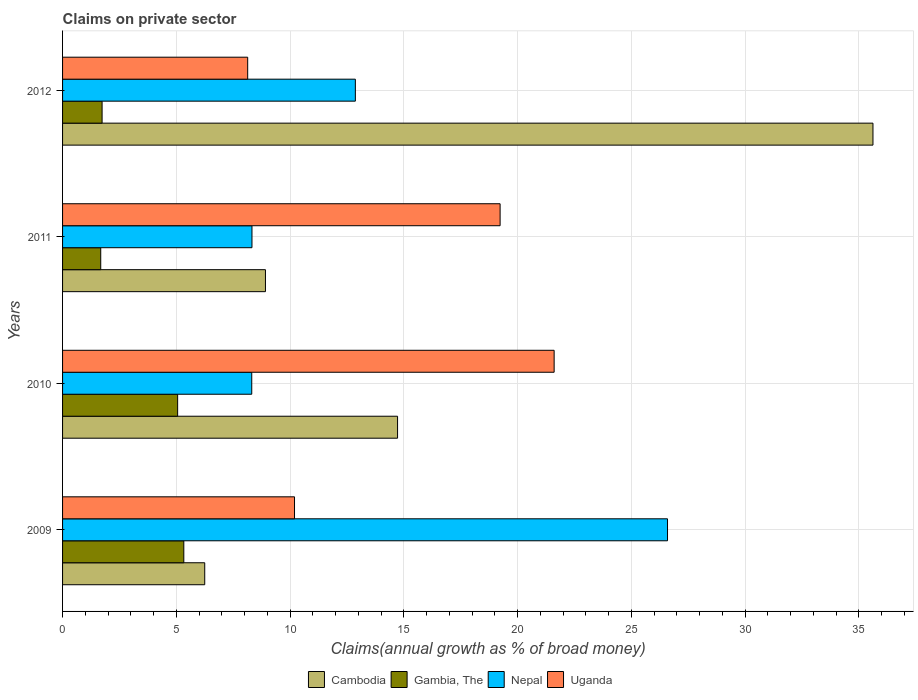How many groups of bars are there?
Your answer should be compact. 4. Are the number of bars on each tick of the Y-axis equal?
Keep it short and to the point. Yes. How many bars are there on the 3rd tick from the top?
Your answer should be compact. 4. How many bars are there on the 4th tick from the bottom?
Offer a terse response. 4. In how many cases, is the number of bars for a given year not equal to the number of legend labels?
Offer a very short reply. 0. What is the percentage of broad money claimed on private sector in Uganda in 2011?
Offer a very short reply. 19.23. Across all years, what is the maximum percentage of broad money claimed on private sector in Nepal?
Make the answer very short. 26.59. Across all years, what is the minimum percentage of broad money claimed on private sector in Uganda?
Your response must be concise. 8.14. In which year was the percentage of broad money claimed on private sector in Uganda maximum?
Your answer should be compact. 2010. What is the total percentage of broad money claimed on private sector in Nepal in the graph?
Your response must be concise. 56.1. What is the difference between the percentage of broad money claimed on private sector in Cambodia in 2009 and that in 2012?
Offer a terse response. -29.37. What is the difference between the percentage of broad money claimed on private sector in Uganda in 2010 and the percentage of broad money claimed on private sector in Nepal in 2009?
Your response must be concise. -4.98. What is the average percentage of broad money claimed on private sector in Nepal per year?
Offer a terse response. 14.03. In the year 2011, what is the difference between the percentage of broad money claimed on private sector in Uganda and percentage of broad money claimed on private sector in Cambodia?
Give a very brief answer. 10.31. What is the ratio of the percentage of broad money claimed on private sector in Gambia, The in 2010 to that in 2012?
Provide a succinct answer. 2.91. Is the difference between the percentage of broad money claimed on private sector in Uganda in 2010 and 2012 greater than the difference between the percentage of broad money claimed on private sector in Cambodia in 2010 and 2012?
Give a very brief answer. Yes. What is the difference between the highest and the second highest percentage of broad money claimed on private sector in Nepal?
Offer a terse response. 13.72. What is the difference between the highest and the lowest percentage of broad money claimed on private sector in Uganda?
Provide a short and direct response. 13.47. In how many years, is the percentage of broad money claimed on private sector in Cambodia greater than the average percentage of broad money claimed on private sector in Cambodia taken over all years?
Give a very brief answer. 1. Is the sum of the percentage of broad money claimed on private sector in Uganda in 2009 and 2011 greater than the maximum percentage of broad money claimed on private sector in Gambia, The across all years?
Offer a terse response. Yes. Is it the case that in every year, the sum of the percentage of broad money claimed on private sector in Nepal and percentage of broad money claimed on private sector in Gambia, The is greater than the sum of percentage of broad money claimed on private sector in Uganda and percentage of broad money claimed on private sector in Cambodia?
Offer a terse response. No. What does the 4th bar from the top in 2012 represents?
Keep it short and to the point. Cambodia. What does the 3rd bar from the bottom in 2010 represents?
Your response must be concise. Nepal. Is it the case that in every year, the sum of the percentage of broad money claimed on private sector in Gambia, The and percentage of broad money claimed on private sector in Nepal is greater than the percentage of broad money claimed on private sector in Uganda?
Give a very brief answer. No. How many bars are there?
Your answer should be very brief. 16. Are all the bars in the graph horizontal?
Your response must be concise. Yes. How many years are there in the graph?
Provide a short and direct response. 4. What is the difference between two consecutive major ticks on the X-axis?
Keep it short and to the point. 5. Are the values on the major ticks of X-axis written in scientific E-notation?
Your answer should be compact. No. Does the graph contain grids?
Offer a terse response. Yes. Where does the legend appear in the graph?
Make the answer very short. Bottom center. How are the legend labels stacked?
Your answer should be compact. Horizontal. What is the title of the graph?
Your response must be concise. Claims on private sector. Does "Togo" appear as one of the legend labels in the graph?
Provide a short and direct response. No. What is the label or title of the X-axis?
Your response must be concise. Claims(annual growth as % of broad money). What is the label or title of the Y-axis?
Offer a terse response. Years. What is the Claims(annual growth as % of broad money) in Cambodia in 2009?
Your answer should be very brief. 6.25. What is the Claims(annual growth as % of broad money) of Gambia, The in 2009?
Provide a short and direct response. 5.33. What is the Claims(annual growth as % of broad money) in Nepal in 2009?
Your answer should be very brief. 26.59. What is the Claims(annual growth as % of broad money) in Uganda in 2009?
Provide a short and direct response. 10.2. What is the Claims(annual growth as % of broad money) in Cambodia in 2010?
Provide a short and direct response. 14.72. What is the Claims(annual growth as % of broad money) of Gambia, The in 2010?
Provide a succinct answer. 5.06. What is the Claims(annual growth as % of broad money) of Nepal in 2010?
Give a very brief answer. 8.32. What is the Claims(annual growth as % of broad money) in Uganda in 2010?
Keep it short and to the point. 21.61. What is the Claims(annual growth as % of broad money) in Cambodia in 2011?
Give a very brief answer. 8.92. What is the Claims(annual growth as % of broad money) of Gambia, The in 2011?
Give a very brief answer. 1.68. What is the Claims(annual growth as % of broad money) in Nepal in 2011?
Ensure brevity in your answer.  8.33. What is the Claims(annual growth as % of broad money) in Uganda in 2011?
Offer a very short reply. 19.23. What is the Claims(annual growth as % of broad money) of Cambodia in 2012?
Your answer should be very brief. 35.62. What is the Claims(annual growth as % of broad money) in Gambia, The in 2012?
Your response must be concise. 1.74. What is the Claims(annual growth as % of broad money) of Nepal in 2012?
Provide a succinct answer. 12.87. What is the Claims(annual growth as % of broad money) in Uganda in 2012?
Keep it short and to the point. 8.14. Across all years, what is the maximum Claims(annual growth as % of broad money) of Cambodia?
Provide a short and direct response. 35.62. Across all years, what is the maximum Claims(annual growth as % of broad money) of Gambia, The?
Provide a short and direct response. 5.33. Across all years, what is the maximum Claims(annual growth as % of broad money) of Nepal?
Provide a succinct answer. 26.59. Across all years, what is the maximum Claims(annual growth as % of broad money) of Uganda?
Your answer should be compact. 21.61. Across all years, what is the minimum Claims(annual growth as % of broad money) of Cambodia?
Offer a very short reply. 6.25. Across all years, what is the minimum Claims(annual growth as % of broad money) in Gambia, The?
Ensure brevity in your answer.  1.68. Across all years, what is the minimum Claims(annual growth as % of broad money) of Nepal?
Your answer should be very brief. 8.32. Across all years, what is the minimum Claims(annual growth as % of broad money) of Uganda?
Your response must be concise. 8.14. What is the total Claims(annual growth as % of broad money) of Cambodia in the graph?
Provide a succinct answer. 65.51. What is the total Claims(annual growth as % of broad money) in Gambia, The in the graph?
Provide a short and direct response. 13.8. What is the total Claims(annual growth as % of broad money) of Nepal in the graph?
Offer a very short reply. 56.1. What is the total Claims(annual growth as % of broad money) of Uganda in the graph?
Provide a succinct answer. 59.17. What is the difference between the Claims(annual growth as % of broad money) in Cambodia in 2009 and that in 2010?
Ensure brevity in your answer.  -8.48. What is the difference between the Claims(annual growth as % of broad money) of Gambia, The in 2009 and that in 2010?
Offer a terse response. 0.27. What is the difference between the Claims(annual growth as % of broad money) of Nepal in 2009 and that in 2010?
Offer a very short reply. 18.27. What is the difference between the Claims(annual growth as % of broad money) in Uganda in 2009 and that in 2010?
Offer a terse response. -11.41. What is the difference between the Claims(annual growth as % of broad money) of Cambodia in 2009 and that in 2011?
Your answer should be compact. -2.67. What is the difference between the Claims(annual growth as % of broad money) of Gambia, The in 2009 and that in 2011?
Keep it short and to the point. 3.65. What is the difference between the Claims(annual growth as % of broad money) in Nepal in 2009 and that in 2011?
Offer a very short reply. 18.27. What is the difference between the Claims(annual growth as % of broad money) of Uganda in 2009 and that in 2011?
Keep it short and to the point. -9.04. What is the difference between the Claims(annual growth as % of broad money) in Cambodia in 2009 and that in 2012?
Keep it short and to the point. -29.37. What is the difference between the Claims(annual growth as % of broad money) of Gambia, The in 2009 and that in 2012?
Your response must be concise. 3.59. What is the difference between the Claims(annual growth as % of broad money) of Nepal in 2009 and that in 2012?
Your answer should be very brief. 13.72. What is the difference between the Claims(annual growth as % of broad money) in Uganda in 2009 and that in 2012?
Offer a very short reply. 2.06. What is the difference between the Claims(annual growth as % of broad money) of Cambodia in 2010 and that in 2011?
Your answer should be very brief. 5.81. What is the difference between the Claims(annual growth as % of broad money) of Gambia, The in 2010 and that in 2011?
Make the answer very short. 3.38. What is the difference between the Claims(annual growth as % of broad money) of Nepal in 2010 and that in 2011?
Your response must be concise. -0.01. What is the difference between the Claims(annual growth as % of broad money) of Uganda in 2010 and that in 2011?
Give a very brief answer. 2.37. What is the difference between the Claims(annual growth as % of broad money) of Cambodia in 2010 and that in 2012?
Your answer should be compact. -20.9. What is the difference between the Claims(annual growth as % of broad money) of Gambia, The in 2010 and that in 2012?
Your response must be concise. 3.32. What is the difference between the Claims(annual growth as % of broad money) in Nepal in 2010 and that in 2012?
Your response must be concise. -4.55. What is the difference between the Claims(annual growth as % of broad money) in Uganda in 2010 and that in 2012?
Your answer should be compact. 13.47. What is the difference between the Claims(annual growth as % of broad money) of Cambodia in 2011 and that in 2012?
Give a very brief answer. -26.7. What is the difference between the Claims(annual growth as % of broad money) of Gambia, The in 2011 and that in 2012?
Make the answer very short. -0.06. What is the difference between the Claims(annual growth as % of broad money) in Nepal in 2011 and that in 2012?
Keep it short and to the point. -4.54. What is the difference between the Claims(annual growth as % of broad money) of Uganda in 2011 and that in 2012?
Ensure brevity in your answer.  11.09. What is the difference between the Claims(annual growth as % of broad money) of Cambodia in 2009 and the Claims(annual growth as % of broad money) of Gambia, The in 2010?
Offer a very short reply. 1.19. What is the difference between the Claims(annual growth as % of broad money) of Cambodia in 2009 and the Claims(annual growth as % of broad money) of Nepal in 2010?
Offer a terse response. -2.07. What is the difference between the Claims(annual growth as % of broad money) in Cambodia in 2009 and the Claims(annual growth as % of broad money) in Uganda in 2010?
Give a very brief answer. -15.36. What is the difference between the Claims(annual growth as % of broad money) in Gambia, The in 2009 and the Claims(annual growth as % of broad money) in Nepal in 2010?
Provide a short and direct response. -2.99. What is the difference between the Claims(annual growth as % of broad money) in Gambia, The in 2009 and the Claims(annual growth as % of broad money) in Uganda in 2010?
Provide a succinct answer. -16.28. What is the difference between the Claims(annual growth as % of broad money) in Nepal in 2009 and the Claims(annual growth as % of broad money) in Uganda in 2010?
Give a very brief answer. 4.98. What is the difference between the Claims(annual growth as % of broad money) of Cambodia in 2009 and the Claims(annual growth as % of broad money) of Gambia, The in 2011?
Provide a succinct answer. 4.57. What is the difference between the Claims(annual growth as % of broad money) in Cambodia in 2009 and the Claims(annual growth as % of broad money) in Nepal in 2011?
Your response must be concise. -2.08. What is the difference between the Claims(annual growth as % of broad money) in Cambodia in 2009 and the Claims(annual growth as % of broad money) in Uganda in 2011?
Provide a short and direct response. -12.98. What is the difference between the Claims(annual growth as % of broad money) in Gambia, The in 2009 and the Claims(annual growth as % of broad money) in Nepal in 2011?
Make the answer very short. -3. What is the difference between the Claims(annual growth as % of broad money) in Gambia, The in 2009 and the Claims(annual growth as % of broad money) in Uganda in 2011?
Offer a very short reply. -13.9. What is the difference between the Claims(annual growth as % of broad money) of Nepal in 2009 and the Claims(annual growth as % of broad money) of Uganda in 2011?
Your response must be concise. 7.36. What is the difference between the Claims(annual growth as % of broad money) of Cambodia in 2009 and the Claims(annual growth as % of broad money) of Gambia, The in 2012?
Offer a very short reply. 4.51. What is the difference between the Claims(annual growth as % of broad money) of Cambodia in 2009 and the Claims(annual growth as % of broad money) of Nepal in 2012?
Your answer should be very brief. -6.62. What is the difference between the Claims(annual growth as % of broad money) of Cambodia in 2009 and the Claims(annual growth as % of broad money) of Uganda in 2012?
Your answer should be compact. -1.89. What is the difference between the Claims(annual growth as % of broad money) in Gambia, The in 2009 and the Claims(annual growth as % of broad money) in Nepal in 2012?
Ensure brevity in your answer.  -7.54. What is the difference between the Claims(annual growth as % of broad money) in Gambia, The in 2009 and the Claims(annual growth as % of broad money) in Uganda in 2012?
Your response must be concise. -2.81. What is the difference between the Claims(annual growth as % of broad money) of Nepal in 2009 and the Claims(annual growth as % of broad money) of Uganda in 2012?
Offer a terse response. 18.45. What is the difference between the Claims(annual growth as % of broad money) in Cambodia in 2010 and the Claims(annual growth as % of broad money) in Gambia, The in 2011?
Offer a very short reply. 13.05. What is the difference between the Claims(annual growth as % of broad money) in Cambodia in 2010 and the Claims(annual growth as % of broad money) in Nepal in 2011?
Your answer should be compact. 6.4. What is the difference between the Claims(annual growth as % of broad money) in Cambodia in 2010 and the Claims(annual growth as % of broad money) in Uganda in 2011?
Your response must be concise. -4.51. What is the difference between the Claims(annual growth as % of broad money) of Gambia, The in 2010 and the Claims(annual growth as % of broad money) of Nepal in 2011?
Provide a short and direct response. -3.27. What is the difference between the Claims(annual growth as % of broad money) in Gambia, The in 2010 and the Claims(annual growth as % of broad money) in Uganda in 2011?
Provide a succinct answer. -14.17. What is the difference between the Claims(annual growth as % of broad money) in Nepal in 2010 and the Claims(annual growth as % of broad money) in Uganda in 2011?
Your response must be concise. -10.92. What is the difference between the Claims(annual growth as % of broad money) in Cambodia in 2010 and the Claims(annual growth as % of broad money) in Gambia, The in 2012?
Keep it short and to the point. 12.99. What is the difference between the Claims(annual growth as % of broad money) in Cambodia in 2010 and the Claims(annual growth as % of broad money) in Nepal in 2012?
Your answer should be compact. 1.85. What is the difference between the Claims(annual growth as % of broad money) in Cambodia in 2010 and the Claims(annual growth as % of broad money) in Uganda in 2012?
Your response must be concise. 6.59. What is the difference between the Claims(annual growth as % of broad money) of Gambia, The in 2010 and the Claims(annual growth as % of broad money) of Nepal in 2012?
Ensure brevity in your answer.  -7.81. What is the difference between the Claims(annual growth as % of broad money) of Gambia, The in 2010 and the Claims(annual growth as % of broad money) of Uganda in 2012?
Your response must be concise. -3.08. What is the difference between the Claims(annual growth as % of broad money) of Nepal in 2010 and the Claims(annual growth as % of broad money) of Uganda in 2012?
Your response must be concise. 0.18. What is the difference between the Claims(annual growth as % of broad money) in Cambodia in 2011 and the Claims(annual growth as % of broad money) in Gambia, The in 2012?
Keep it short and to the point. 7.18. What is the difference between the Claims(annual growth as % of broad money) of Cambodia in 2011 and the Claims(annual growth as % of broad money) of Nepal in 2012?
Your answer should be very brief. -3.95. What is the difference between the Claims(annual growth as % of broad money) in Cambodia in 2011 and the Claims(annual growth as % of broad money) in Uganda in 2012?
Your response must be concise. 0.78. What is the difference between the Claims(annual growth as % of broad money) of Gambia, The in 2011 and the Claims(annual growth as % of broad money) of Nepal in 2012?
Provide a succinct answer. -11.19. What is the difference between the Claims(annual growth as % of broad money) of Gambia, The in 2011 and the Claims(annual growth as % of broad money) of Uganda in 2012?
Make the answer very short. -6.46. What is the difference between the Claims(annual growth as % of broad money) in Nepal in 2011 and the Claims(annual growth as % of broad money) in Uganda in 2012?
Offer a very short reply. 0.19. What is the average Claims(annual growth as % of broad money) of Cambodia per year?
Your response must be concise. 16.38. What is the average Claims(annual growth as % of broad money) in Gambia, The per year?
Make the answer very short. 3.45. What is the average Claims(annual growth as % of broad money) of Nepal per year?
Give a very brief answer. 14.03. What is the average Claims(annual growth as % of broad money) in Uganda per year?
Provide a short and direct response. 14.79. In the year 2009, what is the difference between the Claims(annual growth as % of broad money) of Cambodia and Claims(annual growth as % of broad money) of Gambia, The?
Your answer should be very brief. 0.92. In the year 2009, what is the difference between the Claims(annual growth as % of broad money) in Cambodia and Claims(annual growth as % of broad money) in Nepal?
Keep it short and to the point. -20.34. In the year 2009, what is the difference between the Claims(annual growth as % of broad money) in Cambodia and Claims(annual growth as % of broad money) in Uganda?
Your answer should be very brief. -3.95. In the year 2009, what is the difference between the Claims(annual growth as % of broad money) in Gambia, The and Claims(annual growth as % of broad money) in Nepal?
Keep it short and to the point. -21.26. In the year 2009, what is the difference between the Claims(annual growth as % of broad money) in Gambia, The and Claims(annual growth as % of broad money) in Uganda?
Your answer should be compact. -4.87. In the year 2009, what is the difference between the Claims(annual growth as % of broad money) in Nepal and Claims(annual growth as % of broad money) in Uganda?
Offer a very short reply. 16.4. In the year 2010, what is the difference between the Claims(annual growth as % of broad money) in Cambodia and Claims(annual growth as % of broad money) in Gambia, The?
Keep it short and to the point. 9.67. In the year 2010, what is the difference between the Claims(annual growth as % of broad money) in Cambodia and Claims(annual growth as % of broad money) in Nepal?
Provide a short and direct response. 6.41. In the year 2010, what is the difference between the Claims(annual growth as % of broad money) of Cambodia and Claims(annual growth as % of broad money) of Uganda?
Provide a short and direct response. -6.88. In the year 2010, what is the difference between the Claims(annual growth as % of broad money) in Gambia, The and Claims(annual growth as % of broad money) in Nepal?
Offer a very short reply. -3.26. In the year 2010, what is the difference between the Claims(annual growth as % of broad money) in Gambia, The and Claims(annual growth as % of broad money) in Uganda?
Offer a very short reply. -16.55. In the year 2010, what is the difference between the Claims(annual growth as % of broad money) of Nepal and Claims(annual growth as % of broad money) of Uganda?
Offer a terse response. -13.29. In the year 2011, what is the difference between the Claims(annual growth as % of broad money) in Cambodia and Claims(annual growth as % of broad money) in Gambia, The?
Provide a succinct answer. 7.24. In the year 2011, what is the difference between the Claims(annual growth as % of broad money) in Cambodia and Claims(annual growth as % of broad money) in Nepal?
Offer a terse response. 0.59. In the year 2011, what is the difference between the Claims(annual growth as % of broad money) in Cambodia and Claims(annual growth as % of broad money) in Uganda?
Provide a short and direct response. -10.31. In the year 2011, what is the difference between the Claims(annual growth as % of broad money) in Gambia, The and Claims(annual growth as % of broad money) in Nepal?
Offer a very short reply. -6.65. In the year 2011, what is the difference between the Claims(annual growth as % of broad money) of Gambia, The and Claims(annual growth as % of broad money) of Uganda?
Your answer should be compact. -17.55. In the year 2011, what is the difference between the Claims(annual growth as % of broad money) of Nepal and Claims(annual growth as % of broad money) of Uganda?
Provide a short and direct response. -10.91. In the year 2012, what is the difference between the Claims(annual growth as % of broad money) in Cambodia and Claims(annual growth as % of broad money) in Gambia, The?
Provide a short and direct response. 33.88. In the year 2012, what is the difference between the Claims(annual growth as % of broad money) in Cambodia and Claims(annual growth as % of broad money) in Nepal?
Ensure brevity in your answer.  22.75. In the year 2012, what is the difference between the Claims(annual growth as % of broad money) of Cambodia and Claims(annual growth as % of broad money) of Uganda?
Provide a short and direct response. 27.48. In the year 2012, what is the difference between the Claims(annual growth as % of broad money) of Gambia, The and Claims(annual growth as % of broad money) of Nepal?
Provide a short and direct response. -11.13. In the year 2012, what is the difference between the Claims(annual growth as % of broad money) in Gambia, The and Claims(annual growth as % of broad money) in Uganda?
Your response must be concise. -6.4. In the year 2012, what is the difference between the Claims(annual growth as % of broad money) of Nepal and Claims(annual growth as % of broad money) of Uganda?
Ensure brevity in your answer.  4.73. What is the ratio of the Claims(annual growth as % of broad money) of Cambodia in 2009 to that in 2010?
Make the answer very short. 0.42. What is the ratio of the Claims(annual growth as % of broad money) in Gambia, The in 2009 to that in 2010?
Ensure brevity in your answer.  1.05. What is the ratio of the Claims(annual growth as % of broad money) in Nepal in 2009 to that in 2010?
Ensure brevity in your answer.  3.2. What is the ratio of the Claims(annual growth as % of broad money) of Uganda in 2009 to that in 2010?
Offer a terse response. 0.47. What is the ratio of the Claims(annual growth as % of broad money) of Cambodia in 2009 to that in 2011?
Give a very brief answer. 0.7. What is the ratio of the Claims(annual growth as % of broad money) in Gambia, The in 2009 to that in 2011?
Your answer should be compact. 3.18. What is the ratio of the Claims(annual growth as % of broad money) of Nepal in 2009 to that in 2011?
Your answer should be very brief. 3.19. What is the ratio of the Claims(annual growth as % of broad money) of Uganda in 2009 to that in 2011?
Offer a terse response. 0.53. What is the ratio of the Claims(annual growth as % of broad money) of Cambodia in 2009 to that in 2012?
Offer a very short reply. 0.18. What is the ratio of the Claims(annual growth as % of broad money) in Gambia, The in 2009 to that in 2012?
Ensure brevity in your answer.  3.07. What is the ratio of the Claims(annual growth as % of broad money) of Nepal in 2009 to that in 2012?
Offer a very short reply. 2.07. What is the ratio of the Claims(annual growth as % of broad money) of Uganda in 2009 to that in 2012?
Make the answer very short. 1.25. What is the ratio of the Claims(annual growth as % of broad money) in Cambodia in 2010 to that in 2011?
Your answer should be very brief. 1.65. What is the ratio of the Claims(annual growth as % of broad money) of Gambia, The in 2010 to that in 2011?
Offer a very short reply. 3.02. What is the ratio of the Claims(annual growth as % of broad money) of Nepal in 2010 to that in 2011?
Offer a terse response. 1. What is the ratio of the Claims(annual growth as % of broad money) in Uganda in 2010 to that in 2011?
Your response must be concise. 1.12. What is the ratio of the Claims(annual growth as % of broad money) in Cambodia in 2010 to that in 2012?
Provide a short and direct response. 0.41. What is the ratio of the Claims(annual growth as % of broad money) of Gambia, The in 2010 to that in 2012?
Offer a terse response. 2.91. What is the ratio of the Claims(annual growth as % of broad money) in Nepal in 2010 to that in 2012?
Offer a terse response. 0.65. What is the ratio of the Claims(annual growth as % of broad money) of Uganda in 2010 to that in 2012?
Provide a succinct answer. 2.66. What is the ratio of the Claims(annual growth as % of broad money) of Cambodia in 2011 to that in 2012?
Your answer should be compact. 0.25. What is the ratio of the Claims(annual growth as % of broad money) of Gambia, The in 2011 to that in 2012?
Your answer should be compact. 0.97. What is the ratio of the Claims(annual growth as % of broad money) in Nepal in 2011 to that in 2012?
Make the answer very short. 0.65. What is the ratio of the Claims(annual growth as % of broad money) in Uganda in 2011 to that in 2012?
Provide a succinct answer. 2.36. What is the difference between the highest and the second highest Claims(annual growth as % of broad money) in Cambodia?
Ensure brevity in your answer.  20.9. What is the difference between the highest and the second highest Claims(annual growth as % of broad money) in Gambia, The?
Ensure brevity in your answer.  0.27. What is the difference between the highest and the second highest Claims(annual growth as % of broad money) of Nepal?
Give a very brief answer. 13.72. What is the difference between the highest and the second highest Claims(annual growth as % of broad money) of Uganda?
Your answer should be compact. 2.37. What is the difference between the highest and the lowest Claims(annual growth as % of broad money) of Cambodia?
Your response must be concise. 29.37. What is the difference between the highest and the lowest Claims(annual growth as % of broad money) of Gambia, The?
Provide a short and direct response. 3.65. What is the difference between the highest and the lowest Claims(annual growth as % of broad money) in Nepal?
Your response must be concise. 18.27. What is the difference between the highest and the lowest Claims(annual growth as % of broad money) of Uganda?
Provide a short and direct response. 13.47. 